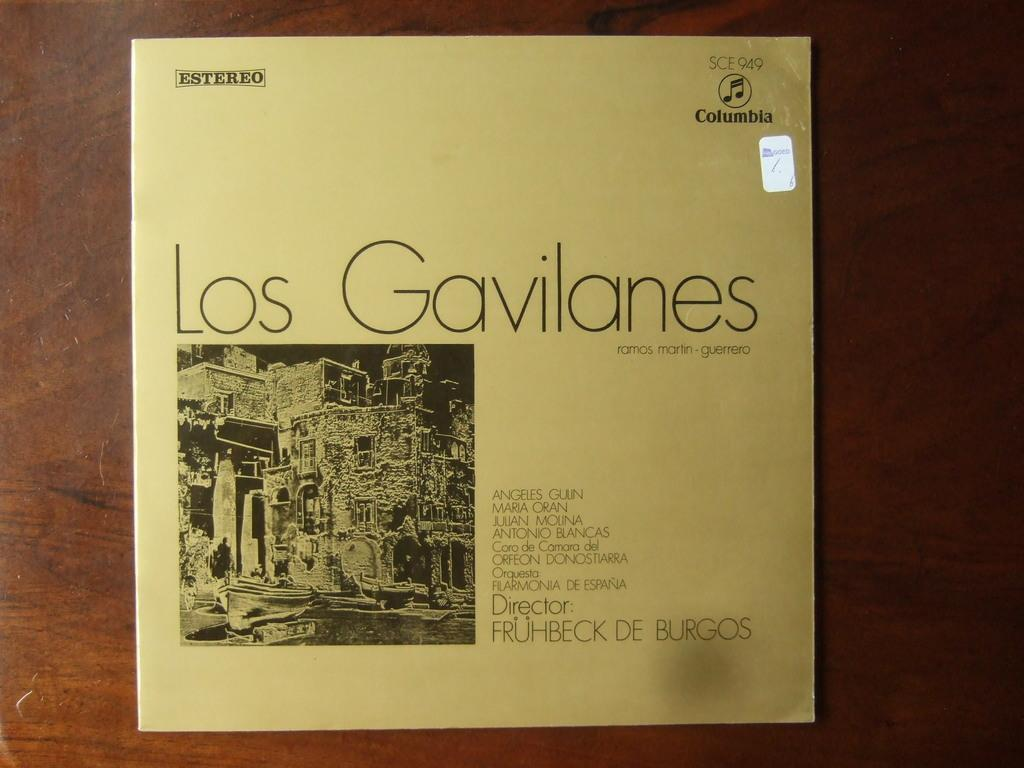<image>
Relay a brief, clear account of the picture shown. a record sleeve that reads Gavilanes is covered by a strange circle.. 